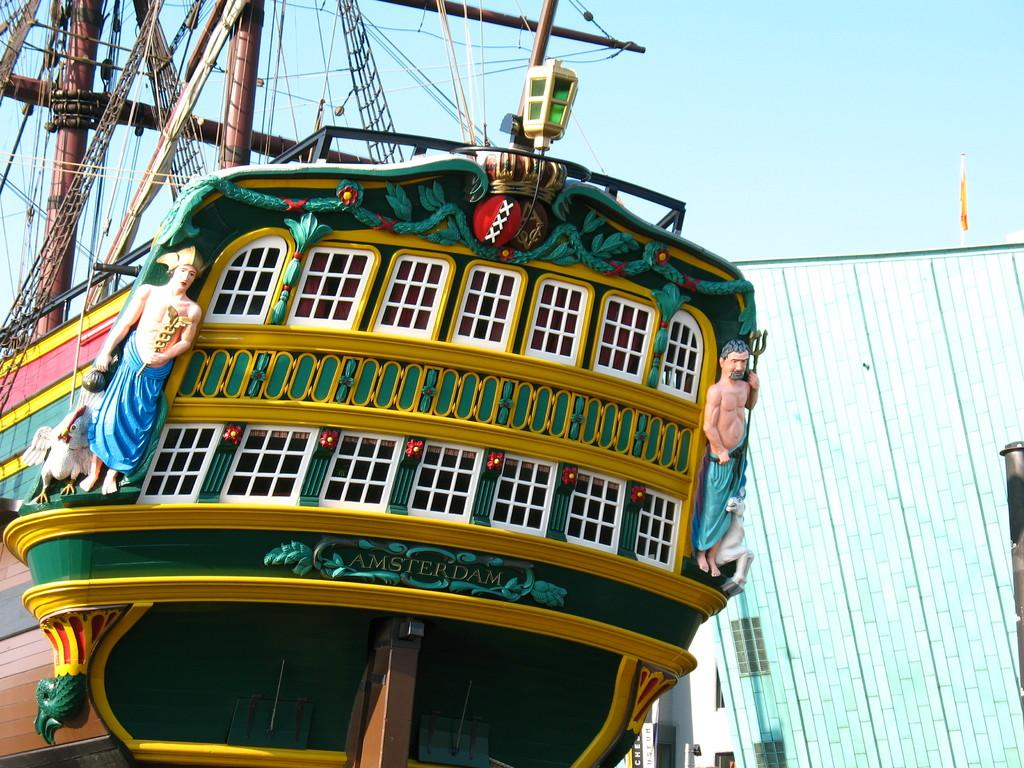What is the main subject of the picture? The main subject of the picture is a ship. What other structures or objects can be seen in the picture? There is a building in the picture. What can be seen in the background of the picture? The sky is visible in the background of the picture. What type of polish is being applied to the ship in the picture? There is no indication in the image that any polish is being applied to the ship. Can you see any stamps on the building in the picture? There is no mention of stamps on the building in the image. 